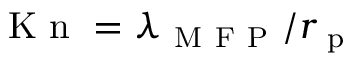<formula> <loc_0><loc_0><loc_500><loc_500>K n = \lambda _ { M F P } / r _ { p }</formula> 